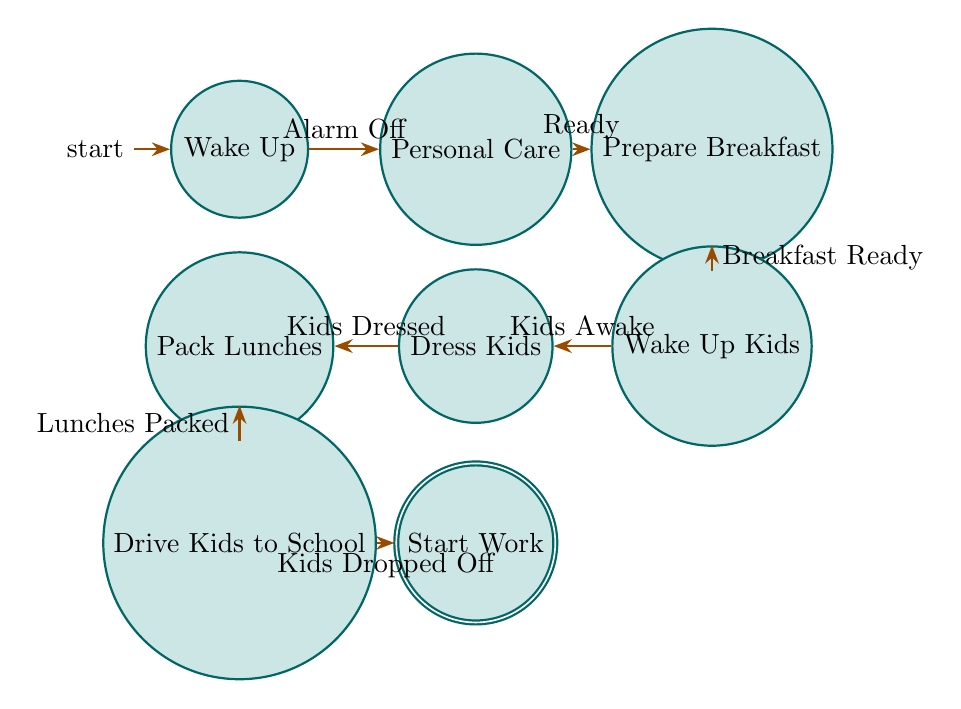What is the starting state of the diagram? The starting state is represented by the initial node, which is "Wake Up".
Answer: Wake Up How many total states are there in the diagram? By counting all the unique states listed, there are eight states in total: Wake Up, Personal Care, Prepare Breakfast, Wake Up Kids, Dress Kids, Pack Lunches, Drive Kids to School, and Start Work.
Answer: 8 What action follows "Pack Lunches"? The transition shows that after "Pack Lunches," the next state is "Drive Kids to School" which corresponds to the action taken when lunches are packed.
Answer: Drive Kids to School What is the action associated with the "Prepare Breakfast" state? The action for the "Prepare Breakfast" state is to "Make a Healthy Breakfast".
Answer: Make a Healthy Breakfast Which state precedes "Start Work"? The state that comes just before "Start Work" is "Drive Kids to School". This is determined by following the transition arrows leading to "Start Work".
Answer: Drive Kids to School What is the trigger to transition from "Wake Up" to "Personal Care"? The trigger for the transition from "Wake Up" to "Personal Care" stated on the edge is "Alarm Off".
Answer: Alarm Off How many transitions are there in the diagram? By analyzing the number of directed edges that connect the states, there are a total of seven transitions.
Answer: 7 What must occur for the state "dress kids" to be reached? To reach "Dress Kids," the previous state must transition from "Wake Up Kids," where the trigger "Kids Awake" must occur.
Answer: Kids Awake What action is taken when the state "Kids Dropped Off" is reached? When the state "Kids Dropped Off" is achieved, the subsequent state reached is "Start Work," which implies that the action taken is to log in and begin working.
Answer: Log in and Begin Working 